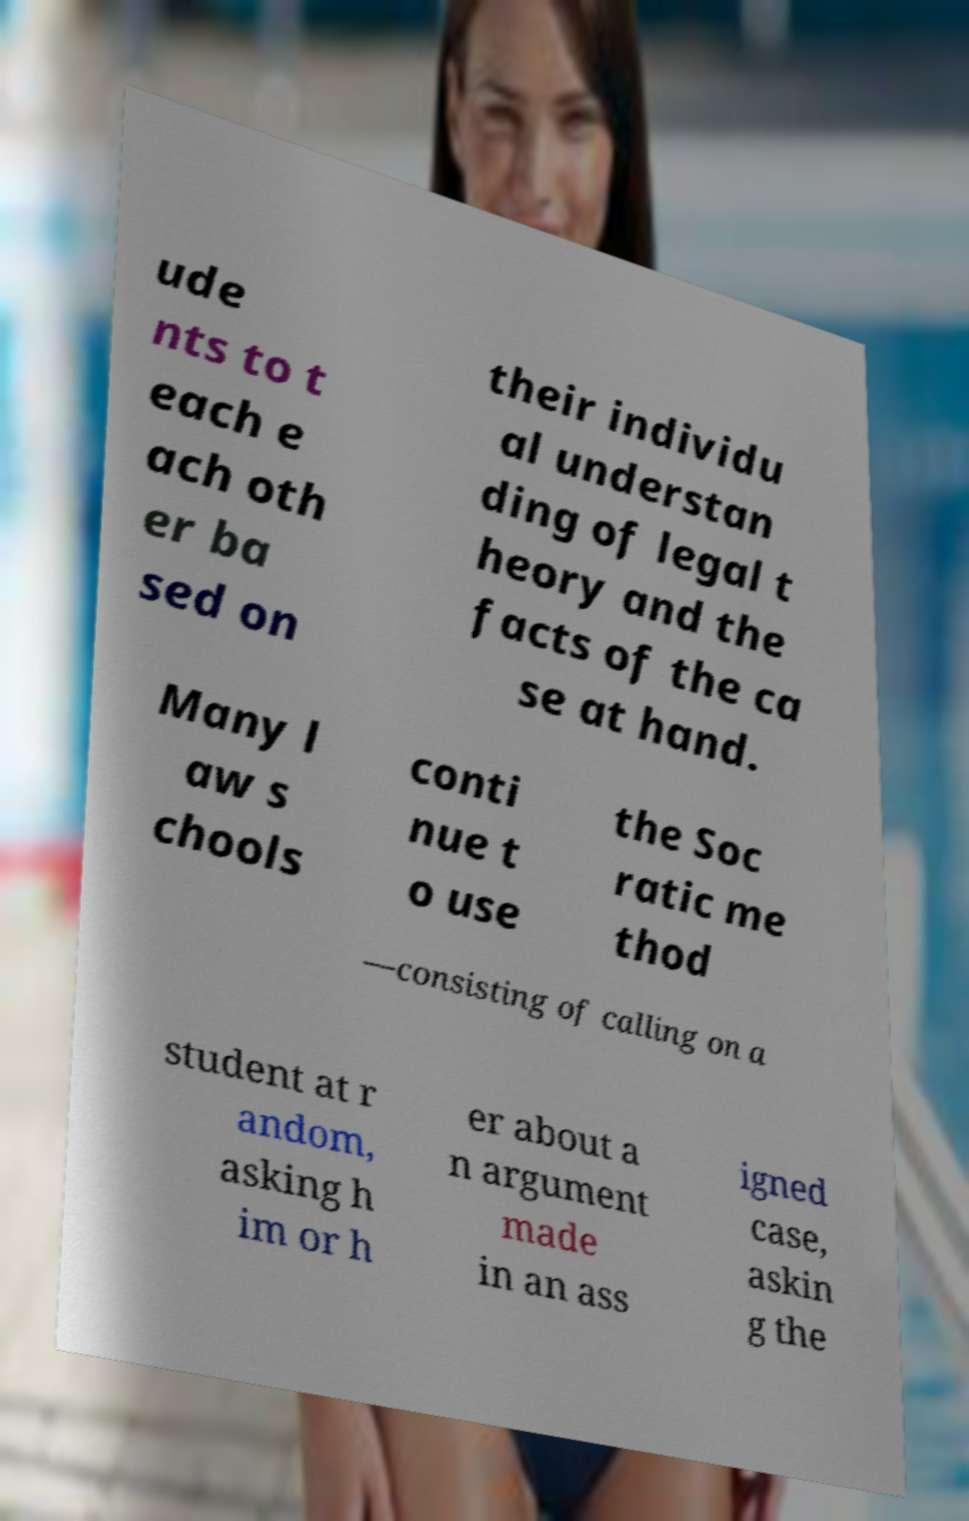Can you accurately transcribe the text from the provided image for me? ude nts to t each e ach oth er ba sed on their individu al understan ding of legal t heory and the facts of the ca se at hand. Many l aw s chools conti nue t o use the Soc ratic me thod —consisting of calling on a student at r andom, asking h im or h er about a n argument made in an ass igned case, askin g the 